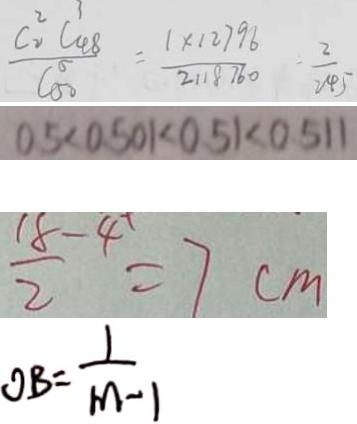<formula> <loc_0><loc_0><loc_500><loc_500>\frac { C _ { 2 } ^ { 2 } C _ { 4 8 } ^ { 3 } } { C _ { 5 0 } ^ { 5 } } = \frac { 1 \times 1 2 7 9 8 } { 2 1 8 7 6 0 } = \frac { 2 } { 2 4 5 } 
 0 . 5 < 0 . 5 0 1 < 0 . 5 1 < 0 . 5 1 1 
 \frac { 1 8 - 4 } { 2 } = 7 c m 
 O B = \frac { 1 } { m - 1 }</formula> 